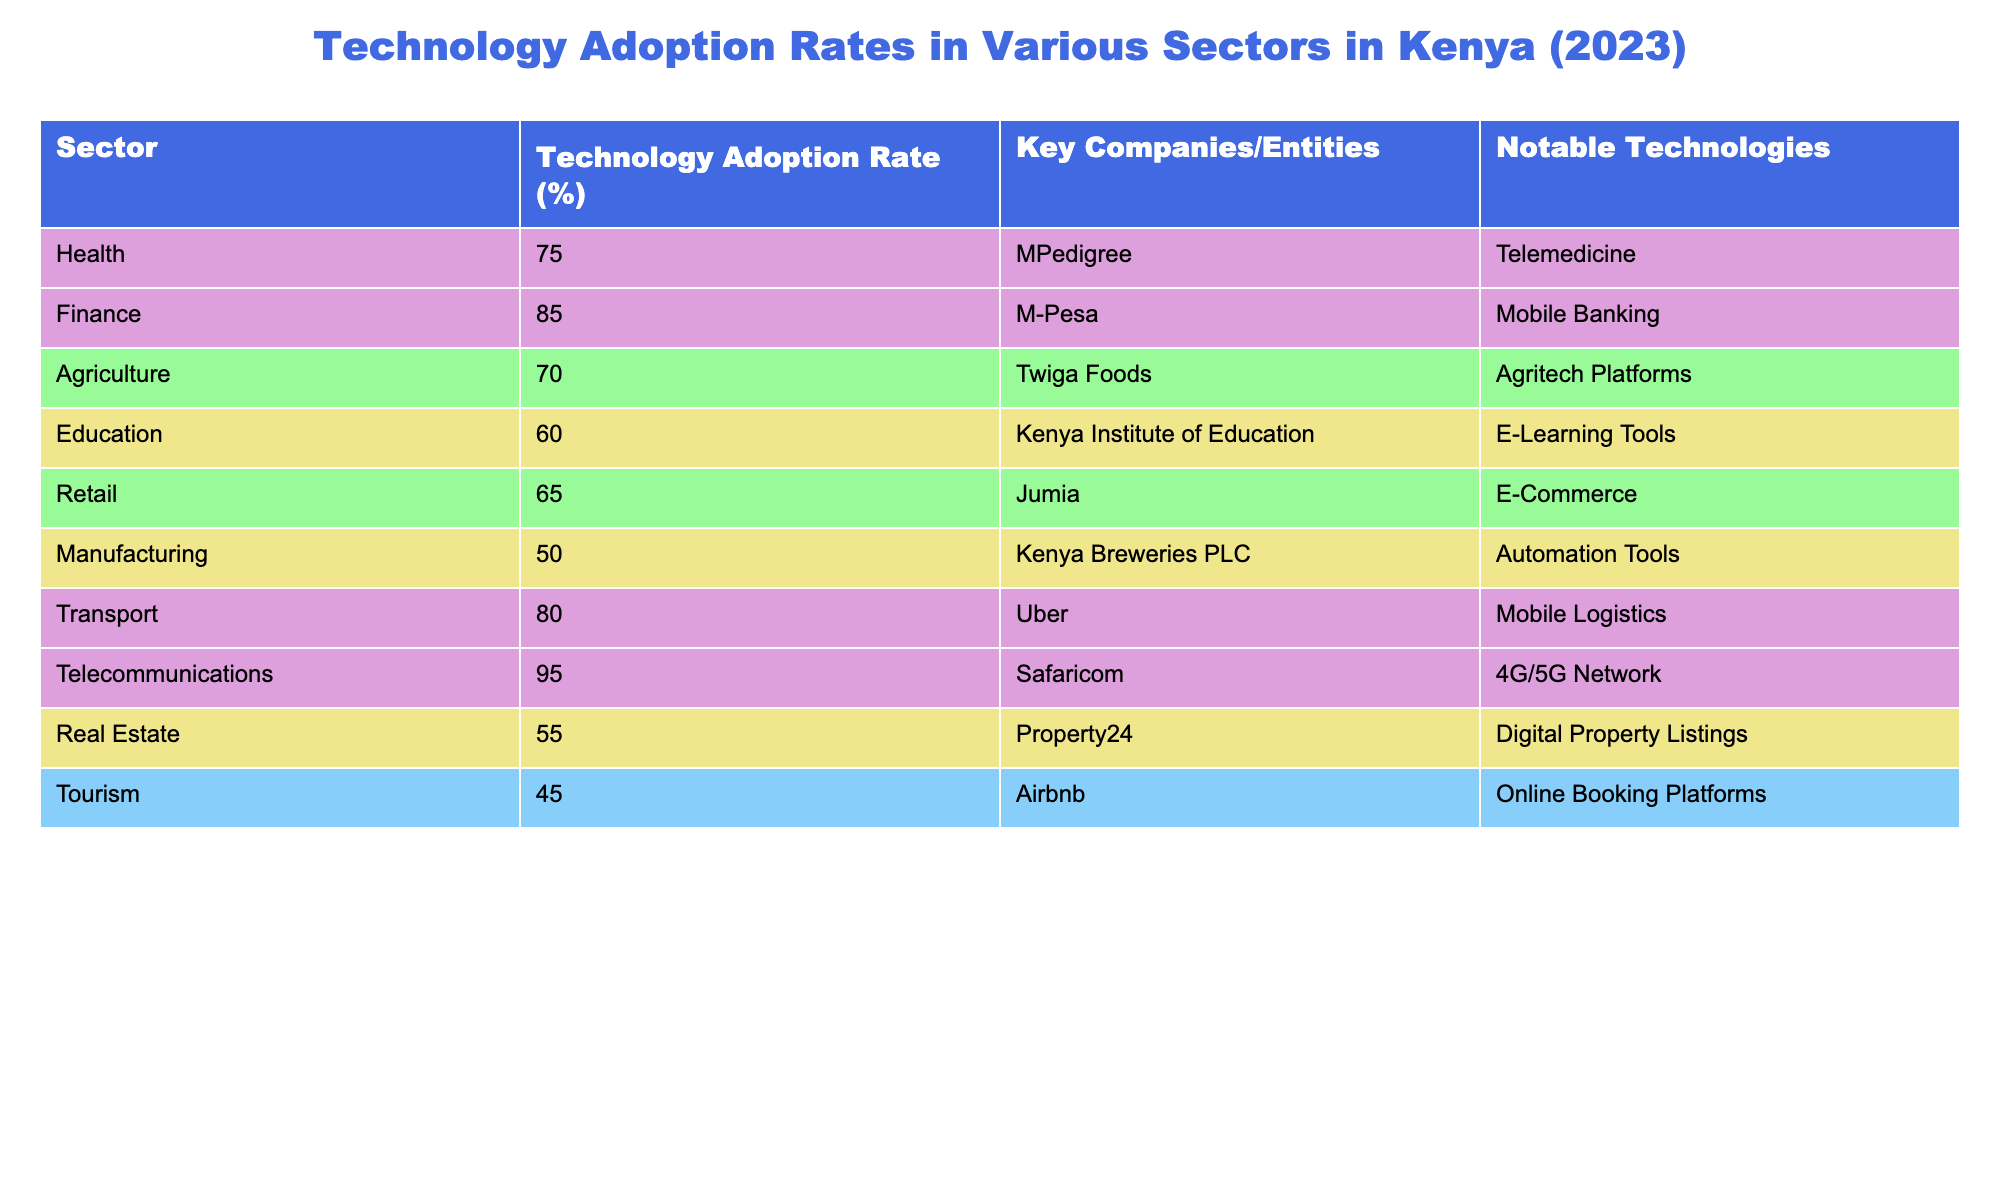What is the technology adoption rate in the telecommunications sector? The telecommunications sector has a technology adoption rate of 95%. This value is obtained directly from the table under the column "Technology Adoption Rate (%)" for the sector labeled "Telecommunications."
Answer: 95% Which sector has the highest technology adoption rate? The sector with the highest technology adoption rate is telecommunications, which has a rate of 95%. This is determined by comparing all the values in the "Technology Adoption Rate (%)" column and identifying the maximum value.
Answer: Telecommunications What is the average technology adoption rate across all sectors listed? To find the average, we sum the technology adoption rates: (75 + 85 + 70 + 60 + 65 + 50 + 80 + 95 + 55 + 45) = 785. There are 10 sectors, so the average is 785 / 10 = 78.5.
Answer: 78.5 Is the technology adoption rate in agriculture higher than in education? The technology adoption rate in agriculture is 70%, while in education, it is 60%. Since 70% > 60%, the statement is true. Therefore, agriculture has a higher adoption rate than education.
Answer: Yes Which sector has a lower technology adoption rate, retail or real estate? Retail has a technology adoption rate of 65%, while real estate has a rate of 55%. Since 55% < 65%, real estate has a lower technology adoption rate. This is determined by comparing the values for retail and real estate in the table.
Answer: Real estate If we combine the technology adoption rates of health and transport, what would be the total? The technology adoption rate for health is 75% and for transport, it is 80%. Adding these together gives us 75 + 80 = 155.
Answer: 155 Are there any sectors with a technology adoption rate lower than 50%? Looking at the table, the lowest adoption rate is in the tourism sector, which has a rate of 45%. Since 45% < 50%, there are indeed sectors with a rate lower than 50%.
Answer: Yes Which sector is closest to the average technology adoption rate? The average is 78.5%. The sectors with rates closest to this average are health (75%) and transport (80%), both within a 3.5% range of the average.
Answer: Health and transport What notable technology is associated with the agriculture sector? The notable technology associated with the agriculture sector is Agritech Platforms. This information is extracted directly from the "Notable Technologies" column for the agriculture sector.
Answer: Agritech Platforms 